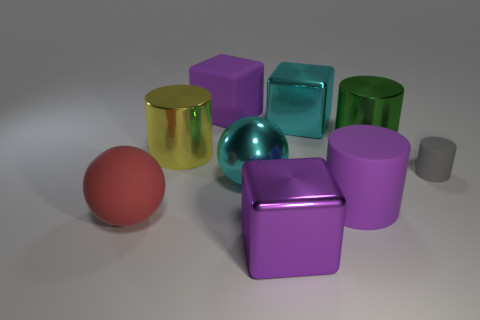What number of matte things are either blue spheres or purple cylinders? 1 